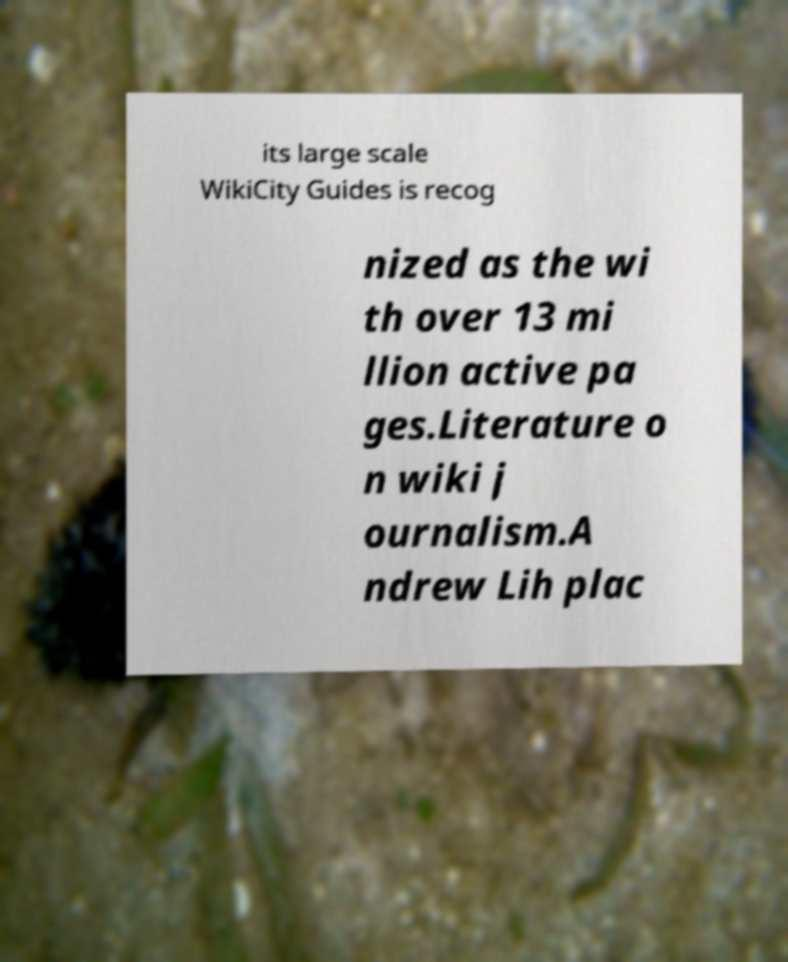Please identify and transcribe the text found in this image. its large scale WikiCity Guides is recog nized as the wi th over 13 mi llion active pa ges.Literature o n wiki j ournalism.A ndrew Lih plac 